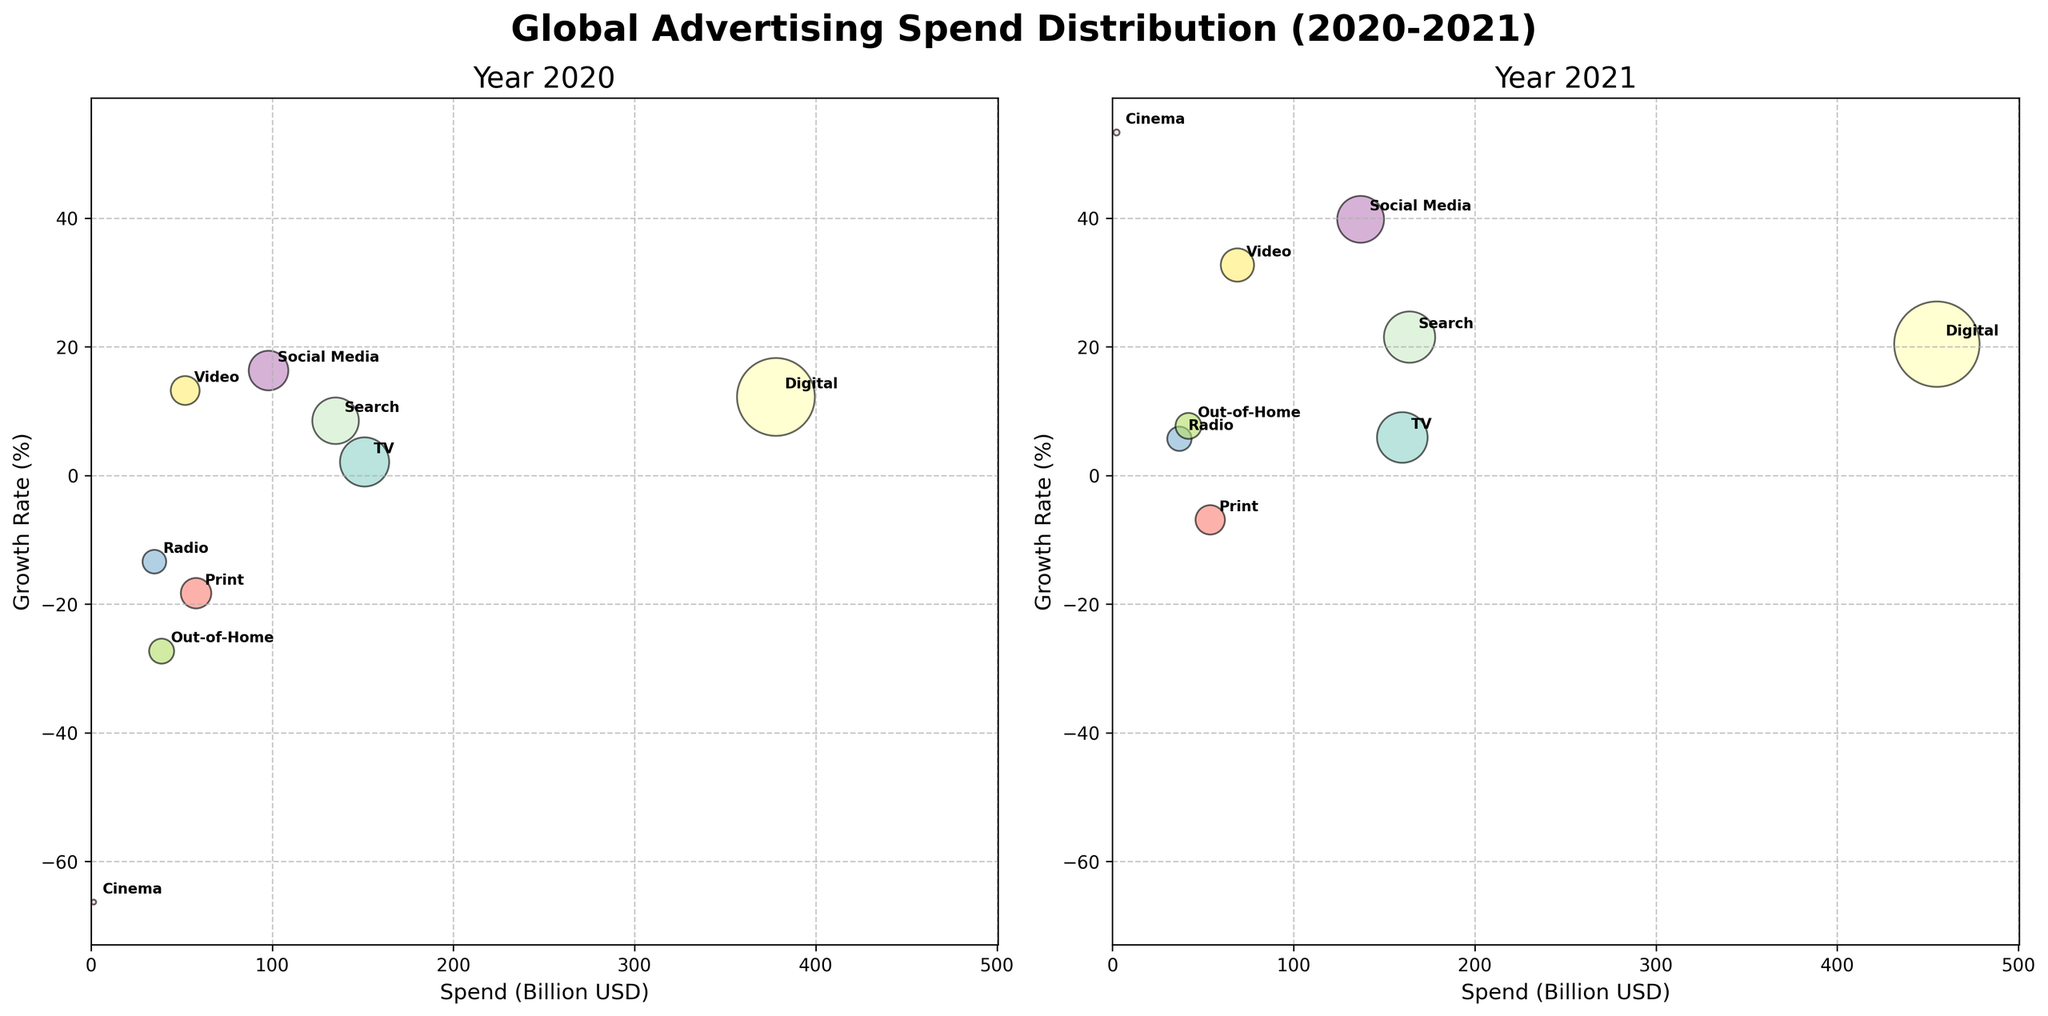What's the title of the subplot? The title is located at the top center of the figure. It reads 'Global Advertising Spend Distribution (2020-2021)', indicating the scope and time period of the data presented.
Answer: Global Advertising Spend Distribution (2020-2021) How many media channels are shown in each year's subplot? By looking at the annotations on each bubble, we can count the distinct media channels present in the subplots for both 2020 and 2021. Each year has annotations for TV, Digital, Print, Radio, Out-of-Home, Cinema, Social Media, Search, and Video.
Answer: 9 Which channel had the highest growth rate in 2021? To find the channel with the highest growth rate, we look at the highest position on the y-axis in the 2021 subplot. The bubble at the highest y-value (53.3%) is annotated with 'Cinema'.
Answer: Cinema What was the growth rate for Radio in 2020 compared to 2021? Locate the bubbles annotated as 'Radio' in both 2020 and 2021 subplots and compare their y-values. In 2020, the growth rate for Radio is -13.4%, while in 2021, it is 5.7%.
Answer: -13.4% in 2020, 5.7% in 2021 Which channel had the largest change in spending from 2020 to 2021? Compare the bubbles from both years. The 'Digital' channel shows the largest spending in both years. In 2020, it was 378 billion USD, and in 2021, it was 455 billion USD. The difference is 77 billion USD.
Answer: Digital What is the overall pattern in growth rates for Social Media from 2020 to 2021? Locate the Social Media bubbles in both subplots. In 2020, its growth rate is plotted around 16.3%, and in 2021, it significantly increased to about 39.8%. This indicates a major upward trend in growth.
Answer: Increasing Which channel had negative growth in both 2020 and 2021? Look at the y-axis for both years and identify the bubbles with negative values. The 'Print' channel has negative growth rates in both 2020 (-18.3%) and 2021 (-6.9%).
Answer: Print What is the average growth rate across all channels in 2020? Add the 2020 growth rates of all channels: 2.1 + 12.2 + (-18.3) + (-13.4) + (-27.3) + (-66.3) + 16.3 + 8.5 + 13.2 = -73.0. There are 9 channels, so the average growth rate is -73.0 / 9 = -8.1%.
Answer: -8.1% Which channel's spending in 2021 did not change much compared to 2020? Compare the x-values from 2020 to 2021 subplots. 'Radio' spending was 35 billion USD in 2020 and 37 billion USD in 2021, showing minimal change.
Answer: Radio 